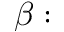Convert formula to latex. <formula><loc_0><loc_0><loc_500><loc_500>\beta \colon</formula> 